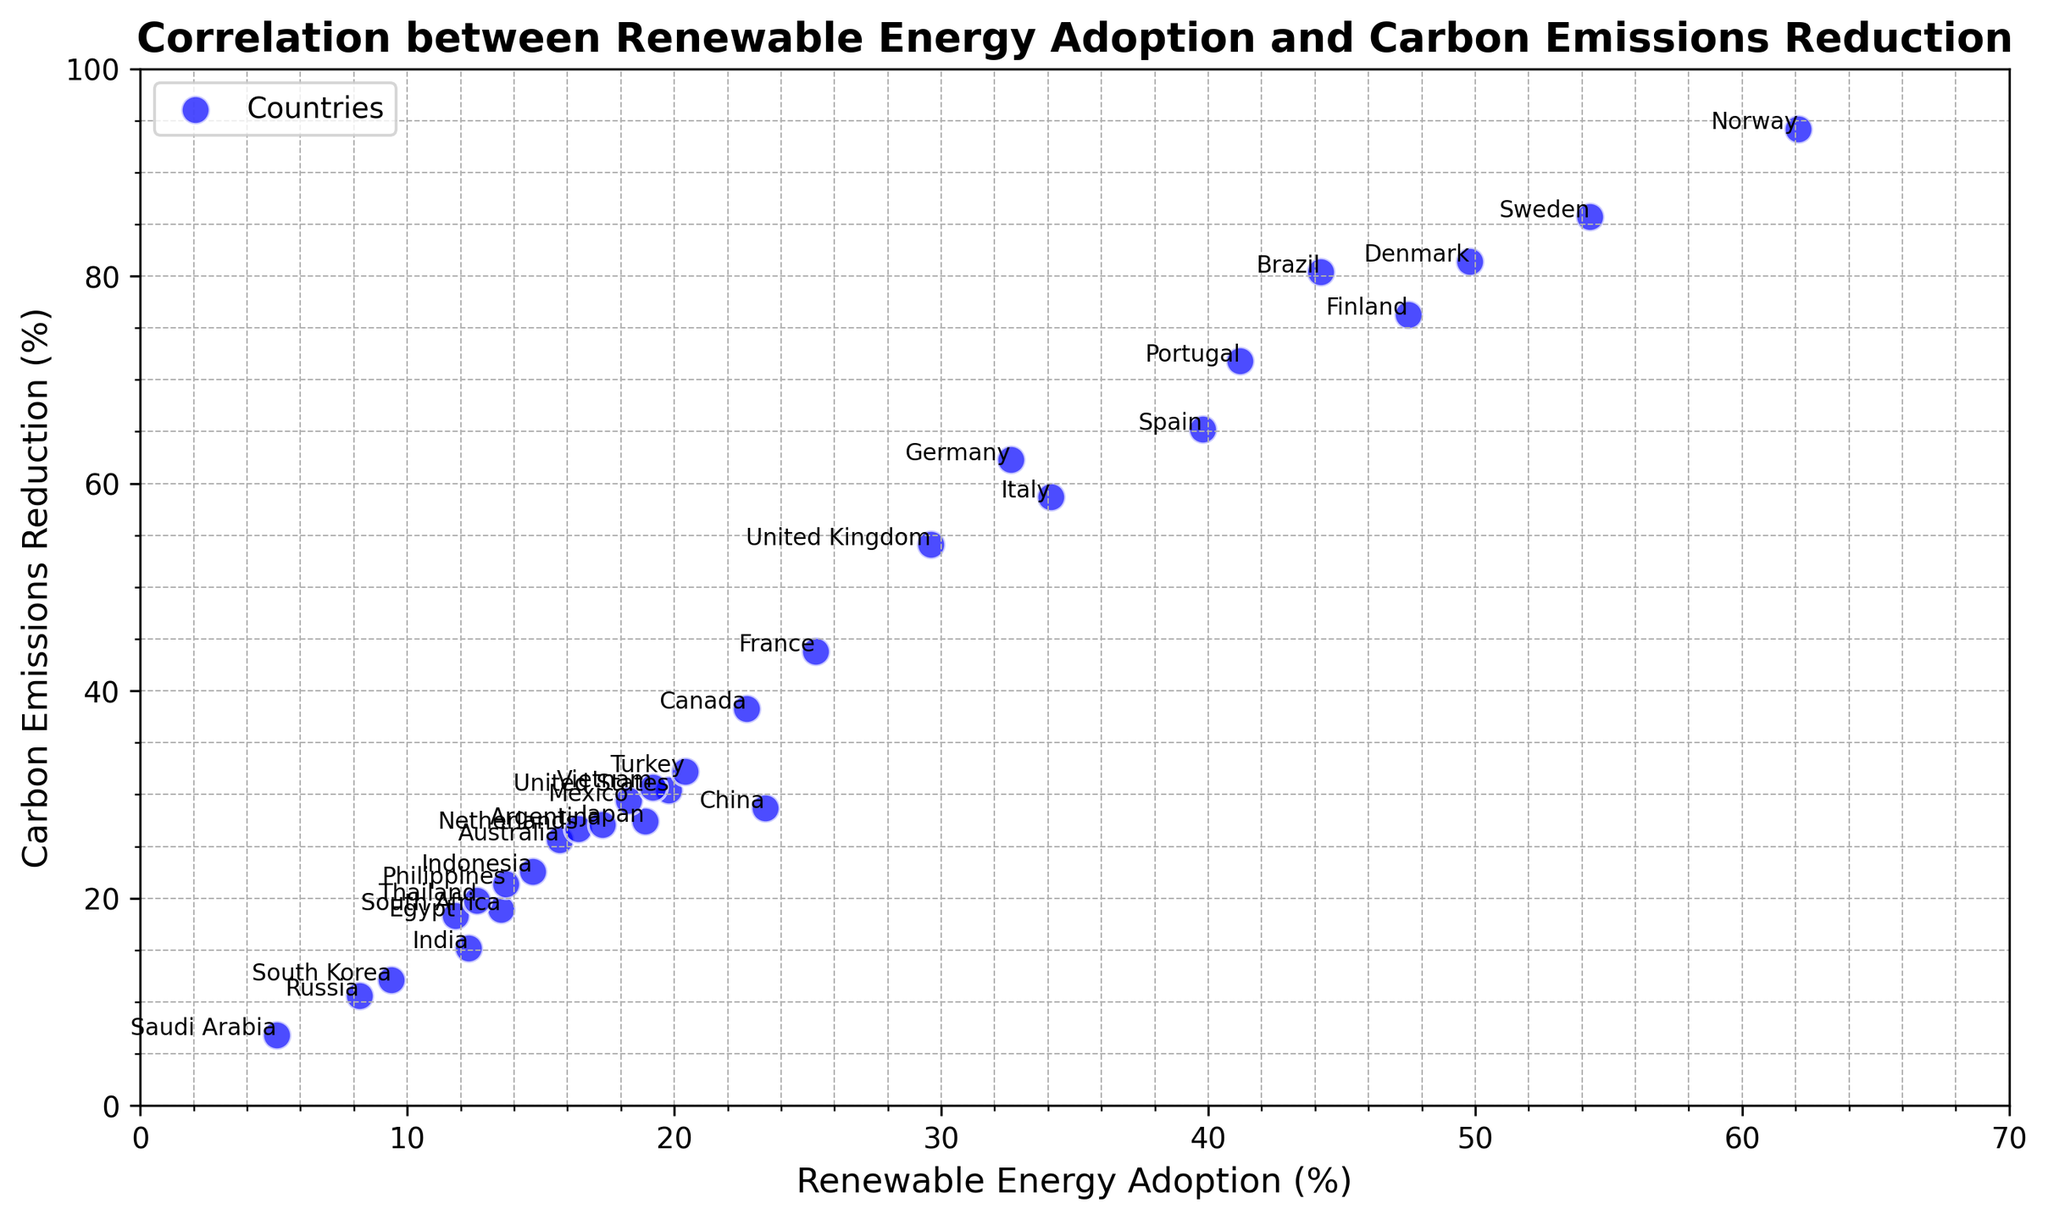Which country has the highest renewable energy adoption and what is its carbon emissions reduction? The country with the highest renewable energy adoption can be identified by locating the point farthest to the right on the x-axis, which is Norway. Norway's carbon emissions reduction is at approximately 94.2% as indicated on the y-axis.
Answer: Norway has 94.2% carbon emissions reduction What is the difference in carbon emissions reduction between Germany and the United States? Locate Germany and the United States on the scatter plot. Germany's carbon emissions reduction is approximately 62.3%, and the United States is 30.4%. Subtract the United States' value from Germany's: 62.3% - 30.4% = 31.9%.
Answer: 31.9% Which countries have more than 50% renewable energy adoption? Find all points on the scatter plot with an x-value greater than 50%. These points correspond to Sweden, Norway, Finland, and Denmark.
Answer: Sweden, Norway, Finland, and Denmark What is the average carbon emissions reduction for the countries with below 20% renewable energy adoption? Identify the points with x-values less than 20%, which are the United States, India, Australia, Japan, South Korea, Netherlands, Mexico, South Africa, Russia, Saudi Arabia, Argentina, Egypt, Indonesia, Thailand, and Philippines. Their y-values are 30.4, 15.2, 25.6, 27.4, 12.1, 26.7, 29.4, 18.9, 10.6, 6.8, 27.1, 18.3, 22.6, 19.8, and 21.4 respectively. Summing these values: 30.4 + 15.2 + 25.6 + 27.4 + 12.1 + 26.7 + 29.4 + 18.9 + 10.6 + 6.8 + 27.1 + 18.3 + 22.6 + 19.8 + 21.4 = 312.7. There are 15 countries, so the average is 312.7 / 15 ≈ 20.8%.
Answer: 20.8% Which two countries are the closest in terms of both renewable energy adoption and carbon emissions reduction? Compare the distances between the points in both axes. The two closest points visually are Thailand and Egypt. Thailand has approximately 12.6% renewable energy adoption and 19.8% carbon emissions reduction, while Egypt has 11.8% renewable energy adoption and 18.3% carbon emissions reduction.
Answer: Thailand and Egypt What is the median carbon emissions reduction for all countries? List all carbon emissions reduction values in ascending order: 6.8, 10.6, 12.1, 12.1, 15.2, 18.3, 18.9, 19.8, 21.4, 22.6, 25.6, 26.7, 27.1, 27.4, 28.7, 29.4, 30.4, 32.2, 38.3, 43.8, 54.1, 58.7, 62.3, 65.2, 71.8, 76.3, 80.4, 81.4, 85.7, 94.2. There are 30 values, so the median is the average of the 15th and 16th values: (28.7 + 29.4) / 2 ≈ 29%.
Answer: 29% 